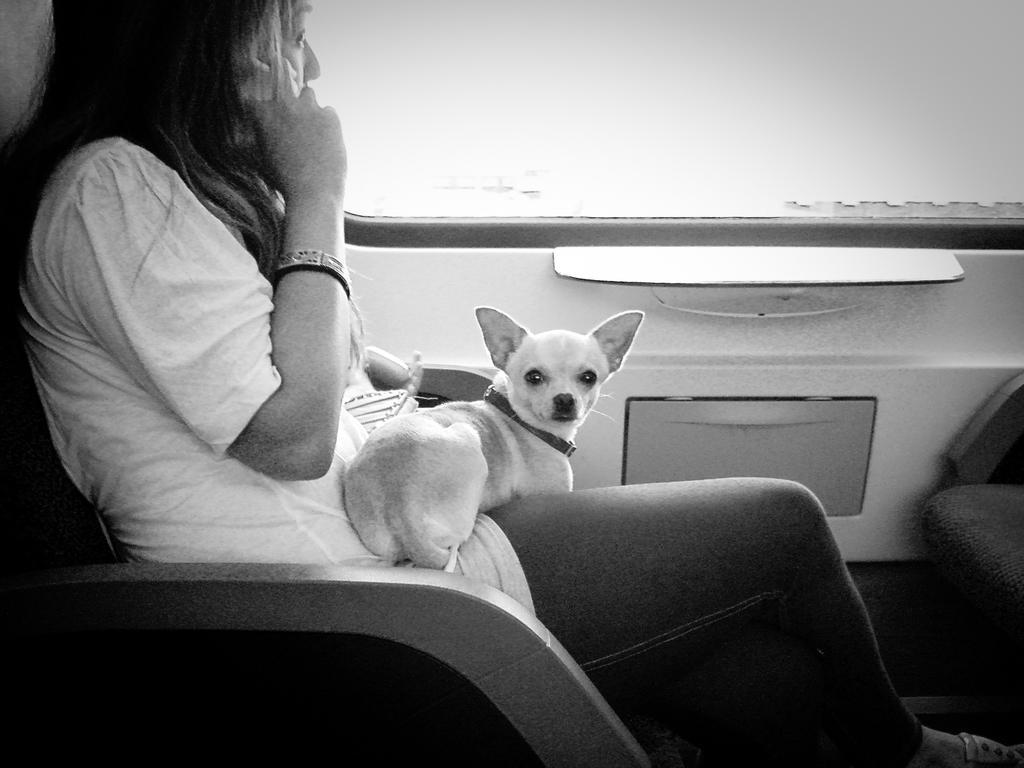How would you summarize this image in a sentence or two? This is a black and white image. In this image we can see a woman sitting on the seat of a motor vehicle and a dog on her lap. 